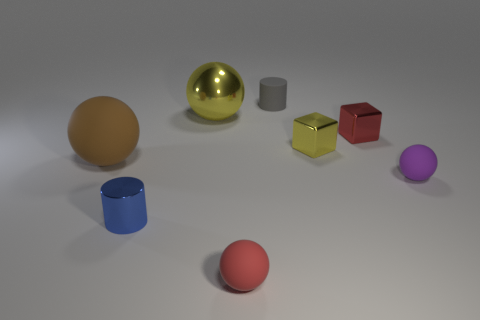Subtract all metal balls. How many balls are left? 3 Subtract all cyan balls. Subtract all blue blocks. How many balls are left? 4 Add 1 small gray rubber objects. How many objects exist? 9 Subtract all cylinders. How many objects are left? 6 Add 1 brown objects. How many brown objects exist? 2 Subtract 1 blue cylinders. How many objects are left? 7 Subtract all big metal things. Subtract all metal things. How many objects are left? 3 Add 2 tiny purple matte balls. How many tiny purple matte balls are left? 3 